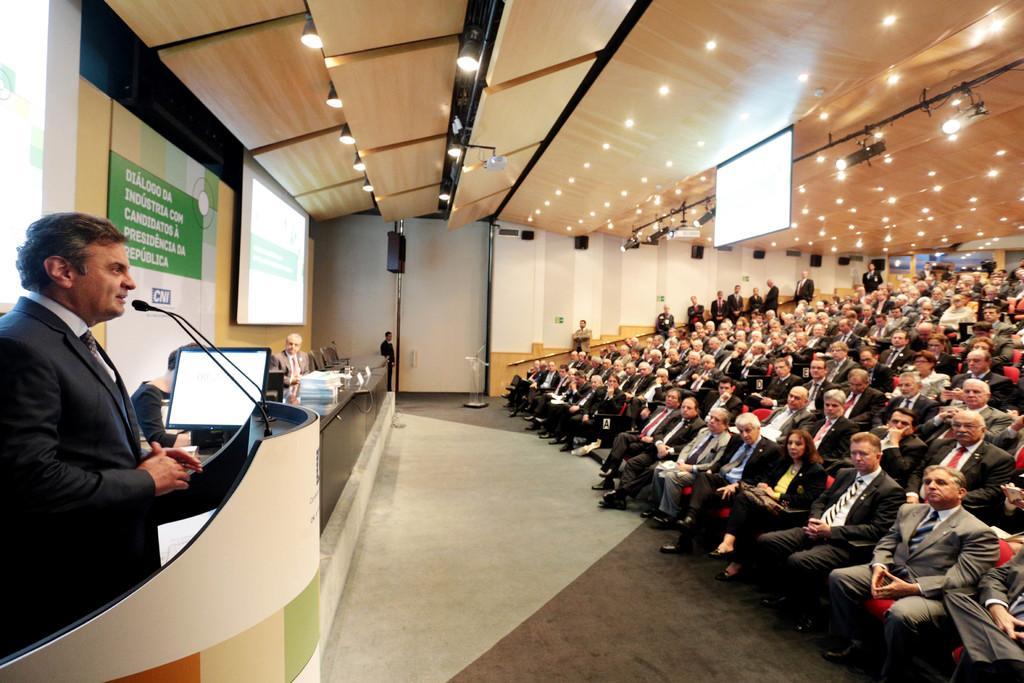How would you summarize this image in a sentence or two? There is a auditorium and many people are sitting in this auditorium. Some of them are standing on the side of the wall. There is a screen and there are some lights in the ceiling. There is some open space in between the stage and the chairs. And near the podium there is guy who is standing and speaking to the audience in the auditorium. In front of these guy there is a monitor. Beside that guy there are some chairs, in front of those chairs there is a table on which some accessories on it. Some of them are sitting in the chairs in front of that table. We can observe lcd projector screen on the wall. 